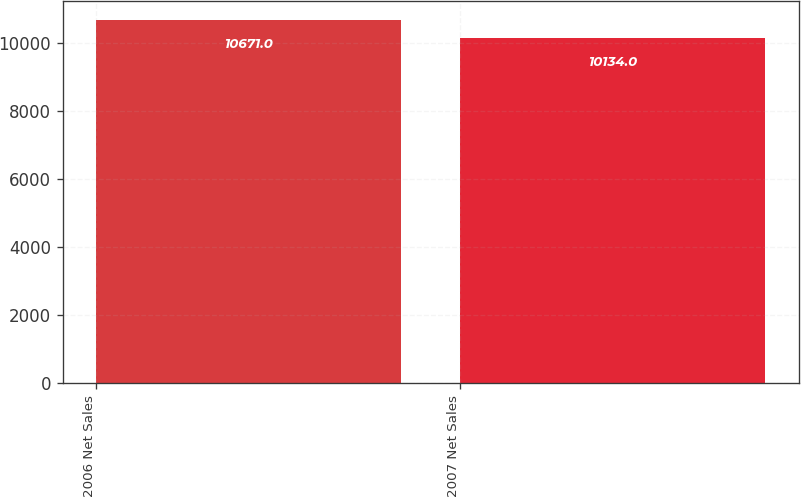Convert chart. <chart><loc_0><loc_0><loc_500><loc_500><bar_chart><fcel>2006 Net Sales<fcel>2007 Net Sales<nl><fcel>10671<fcel>10134<nl></chart> 